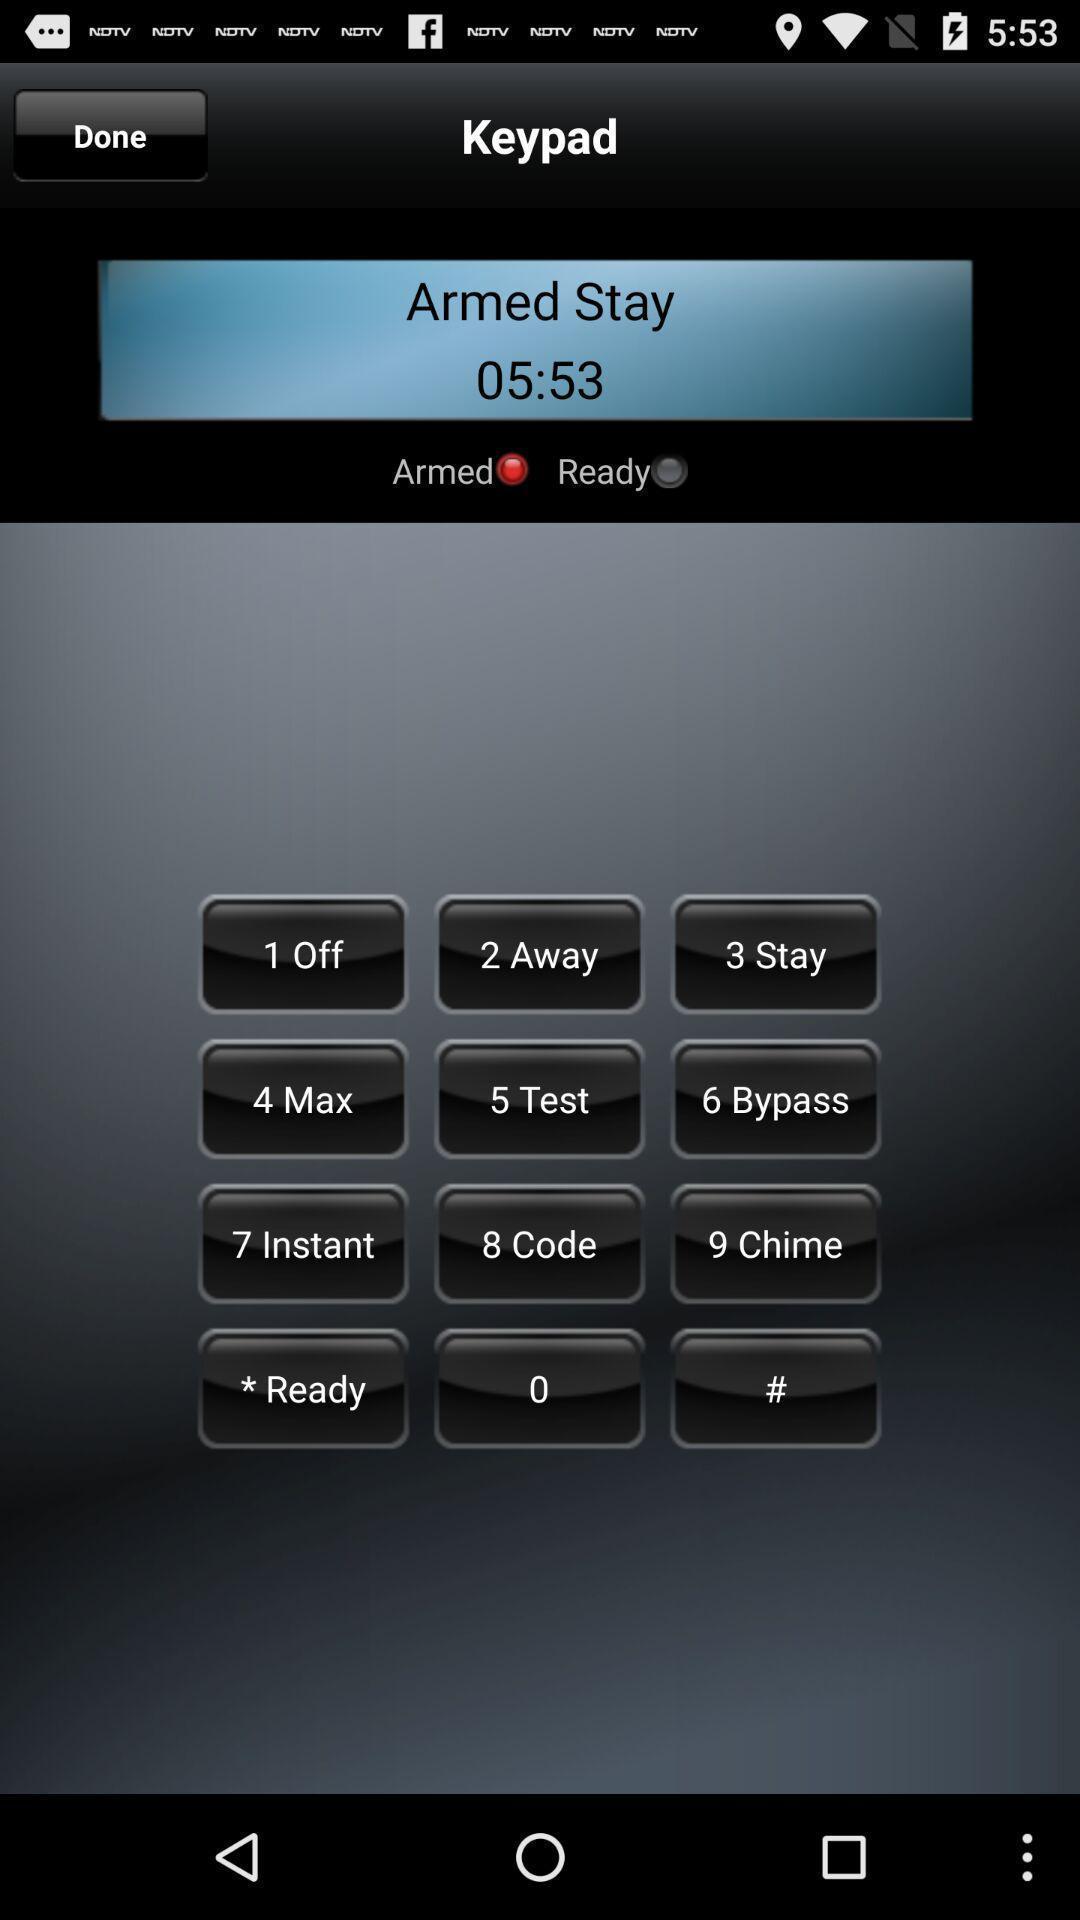Describe the content in this image. Page displaying keypad. 